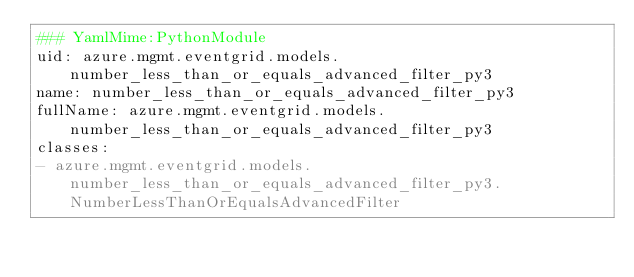<code> <loc_0><loc_0><loc_500><loc_500><_YAML_>### YamlMime:PythonModule
uid: azure.mgmt.eventgrid.models.number_less_than_or_equals_advanced_filter_py3
name: number_less_than_or_equals_advanced_filter_py3
fullName: azure.mgmt.eventgrid.models.number_less_than_or_equals_advanced_filter_py3
classes:
- azure.mgmt.eventgrid.models.number_less_than_or_equals_advanced_filter_py3.NumberLessThanOrEqualsAdvancedFilter
</code> 